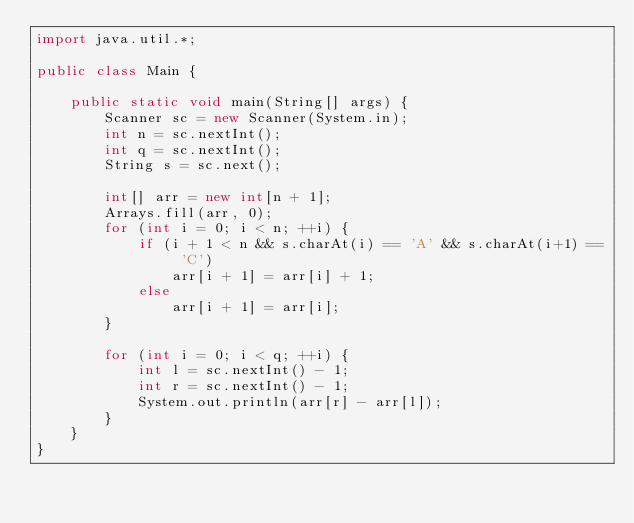Convert code to text. <code><loc_0><loc_0><loc_500><loc_500><_Java_>import java.util.*;

public class Main {

    public static void main(String[] args) {
        Scanner sc = new Scanner(System.in);
        int n = sc.nextInt();
        int q = sc.nextInt();
        String s = sc.next();

        int[] arr = new int[n + 1];
        Arrays.fill(arr, 0);
        for (int i = 0; i < n; ++i) {
            if (i + 1 < n && s.charAt(i) == 'A' && s.charAt(i+1) == 'C')
                arr[i + 1] = arr[i] + 1;
            else
                arr[i + 1] = arr[i];
        }

        for (int i = 0; i < q; ++i) {
            int l = sc.nextInt() - 1;
            int r = sc.nextInt() - 1;
            System.out.println(arr[r] - arr[l]);
        }
    }
}</code> 